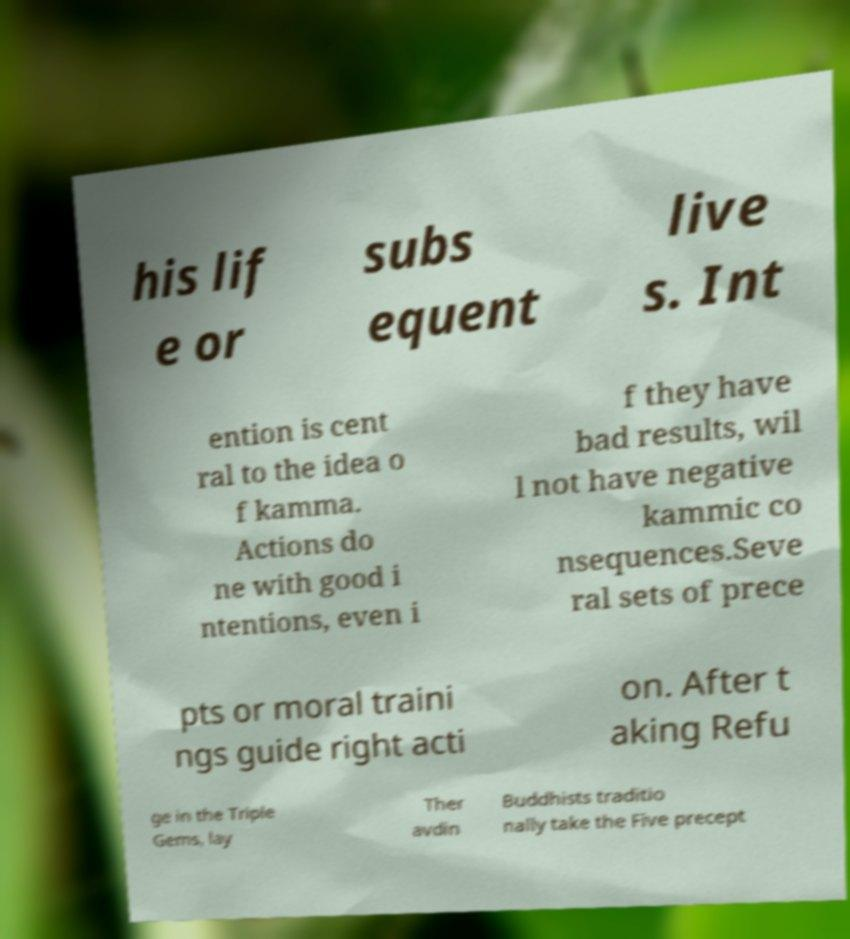What messages or text are displayed in this image? I need them in a readable, typed format. his lif e or subs equent live s. Int ention is cent ral to the idea o f kamma. Actions do ne with good i ntentions, even i f they have bad results, wil l not have negative kammic co nsequences.Seve ral sets of prece pts or moral traini ngs guide right acti on. After t aking Refu ge in the Triple Gems, lay Ther avdin Buddhists traditio nally take the Five precept 